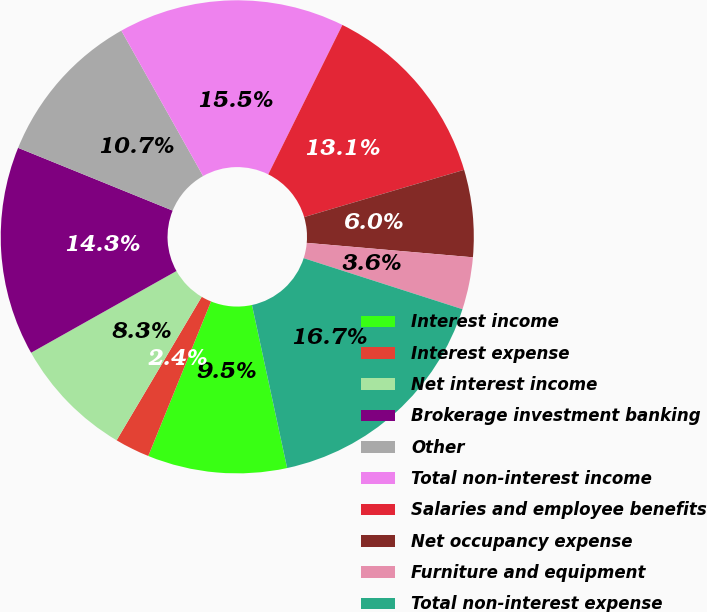Convert chart to OTSL. <chart><loc_0><loc_0><loc_500><loc_500><pie_chart><fcel>Interest income<fcel>Interest expense<fcel>Net interest income<fcel>Brokerage investment banking<fcel>Other<fcel>Total non-interest income<fcel>Salaries and employee benefits<fcel>Net occupancy expense<fcel>Furniture and equipment<fcel>Total non-interest expense<nl><fcel>9.52%<fcel>2.38%<fcel>8.33%<fcel>14.29%<fcel>10.71%<fcel>15.48%<fcel>13.1%<fcel>5.95%<fcel>3.57%<fcel>16.67%<nl></chart> 